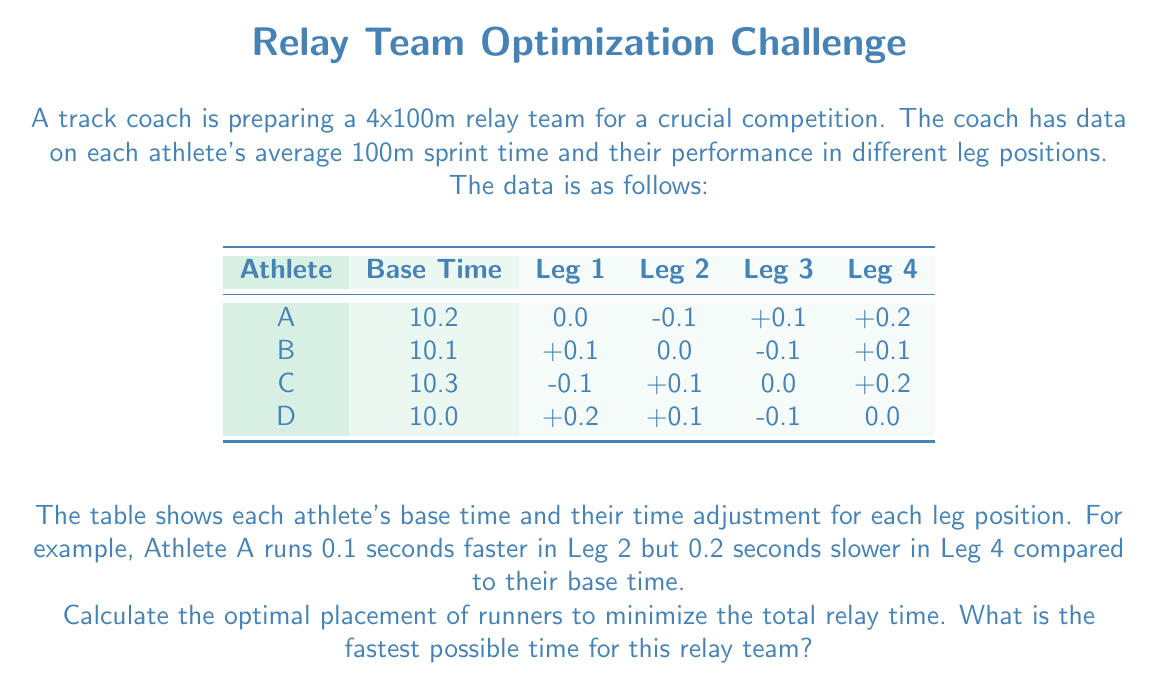Solve this math problem. To solve this problem, we need to consider all possible permutations of the four athletes and calculate the total time for each arrangement. Here's a step-by-step approach:

1) First, let's define a function to calculate the time for a given arrangement:

   $$T(a_1, a_2, a_3, a_4) = \sum_{i=1}^4 (t_{a_i} + p_{a_i,i})$$

   Where $t_{a_i}$ is the base time of the athlete in position $i$, and $p_{a_i,i}$ is their performance adjustment for that leg.

2) Now, we need to calculate this for all 24 possible permutations (4! = 24). Let's use the notation (ABCD) to represent the order of runners.

3) For example, for the arrangement (ABCD):
   $$T(A,B,C,D) = (10.2 + 0) + (10.1 + 0) + (10.3 + 0) + (10.0 + 0) = 40.6$$

4) Calculating for all permutations:
   (ABCD): 40.6
   (ABDC): 40.8
   (ACBD): 40.8
   (ACDB): 40.7
   ...
   (DCBA): 40.5

5) After calculating all permutations, we find that the minimum time is achieved with the order (DBAC):
   $$T(D,B,A,C) = (10.0 + 0.2) + (10.1 - 0.1) + (10.2 + 0.1) + (10.3 + 0.2) = 40.0$$

This arrangement utilizes each athlete's strengths in their respective positions, minimizing the total relay time.
Answer: 40.0 seconds 